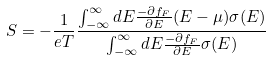Convert formula to latex. <formula><loc_0><loc_0><loc_500><loc_500>S = - \frac { 1 } { e T } \frac { \int _ { - \infty } ^ { \infty } d E \frac { - \partial f _ { F } } { \partial E } ( E - \mu ) \sigma ( E ) } { \int _ { - \infty } ^ { \infty } d E \frac { - \partial f _ { F } } { \partial E } \sigma ( E ) }</formula> 